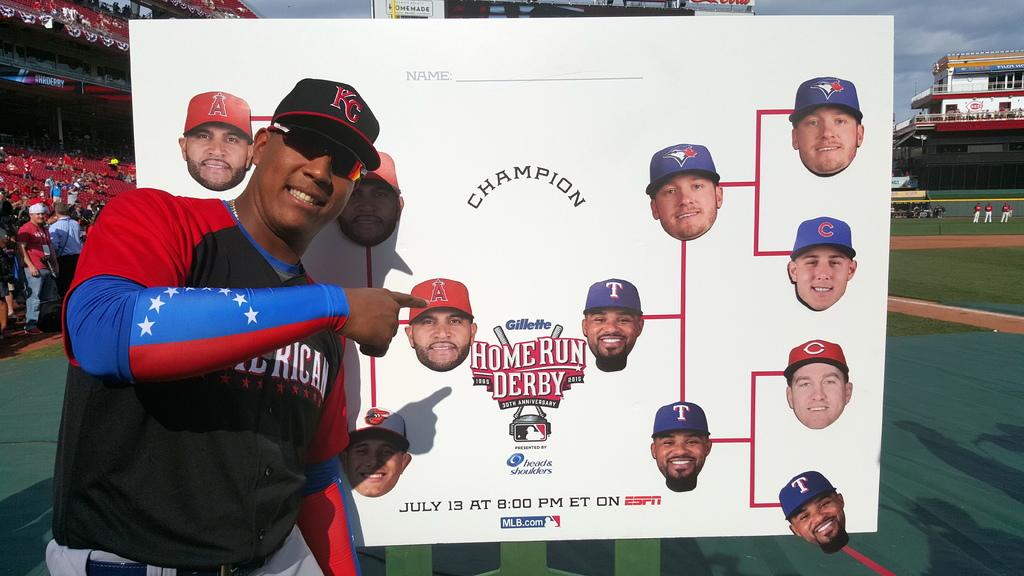What is this sign for?
Give a very brief answer. Home run derby. Is this on espn?
Provide a short and direct response. Yes. 